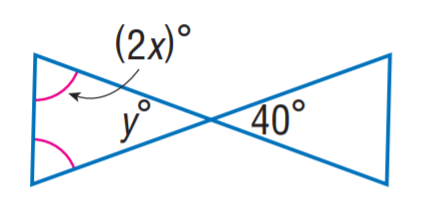Answer the mathemtical geometry problem and directly provide the correct option letter.
Question: Find x.
Choices: A: 30 B: 35 C: 40 D: 45 B 